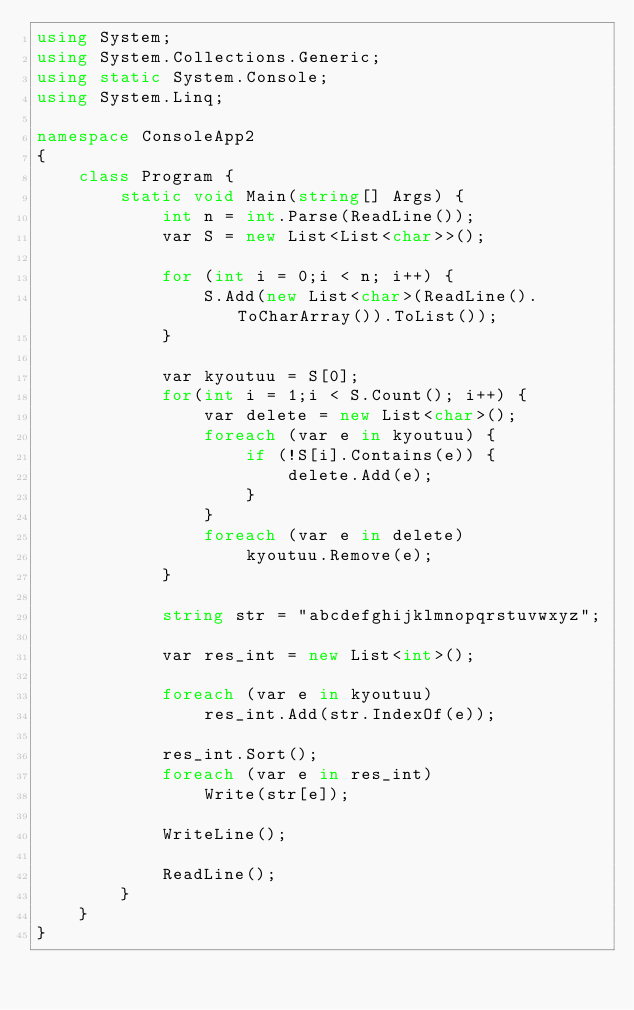Convert code to text. <code><loc_0><loc_0><loc_500><loc_500><_C#_>using System;
using System.Collections.Generic;
using static System.Console;
using System.Linq;

namespace ConsoleApp2
{
    class Program {
        static void Main(string[] Args) {
            int n = int.Parse(ReadLine());
            var S = new List<List<char>>();

            for (int i = 0;i < n; i++) {
                S.Add(new List<char>(ReadLine().ToCharArray()).ToList());
            }

            var kyoutuu = S[0];
            for(int i = 1;i < S.Count(); i++) {
                var delete = new List<char>();
                foreach (var e in kyoutuu) {
                    if (!S[i].Contains(e)) {
                        delete.Add(e);
                    }
                }
                foreach (var e in delete)
                    kyoutuu.Remove(e);
            }

            string str = "abcdefghijklmnopqrstuvwxyz";

            var res_int = new List<int>();

            foreach (var e in kyoutuu)
                res_int.Add(str.IndexOf(e));

            res_int.Sort();
            foreach (var e in res_int)
                Write(str[e]);

            WriteLine();

            ReadLine();
        }
    }
}
</code> 